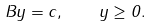Convert formula to latex. <formula><loc_0><loc_0><loc_500><loc_500>B y = c , \quad y \geq 0 .</formula> 